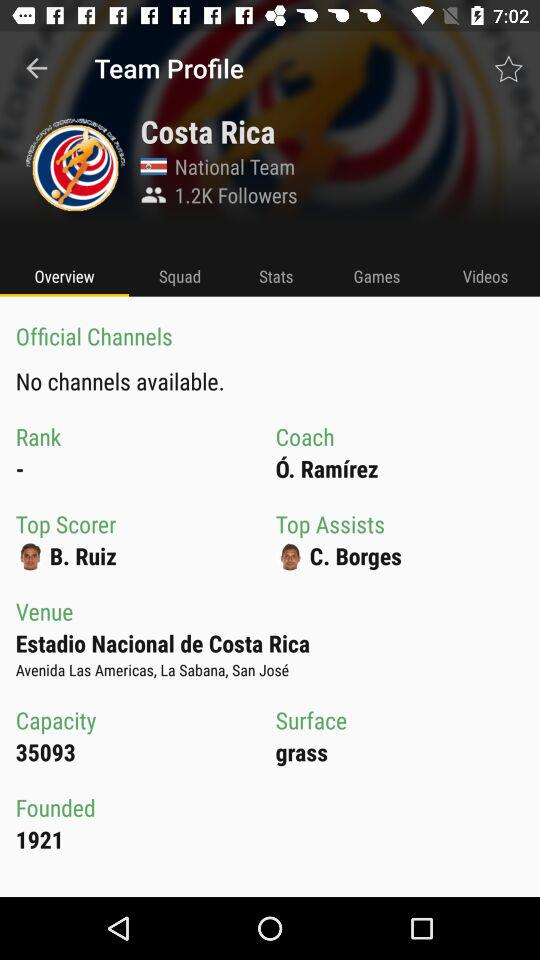Who is the top scorer? The top scorer is B. Ruiz. 